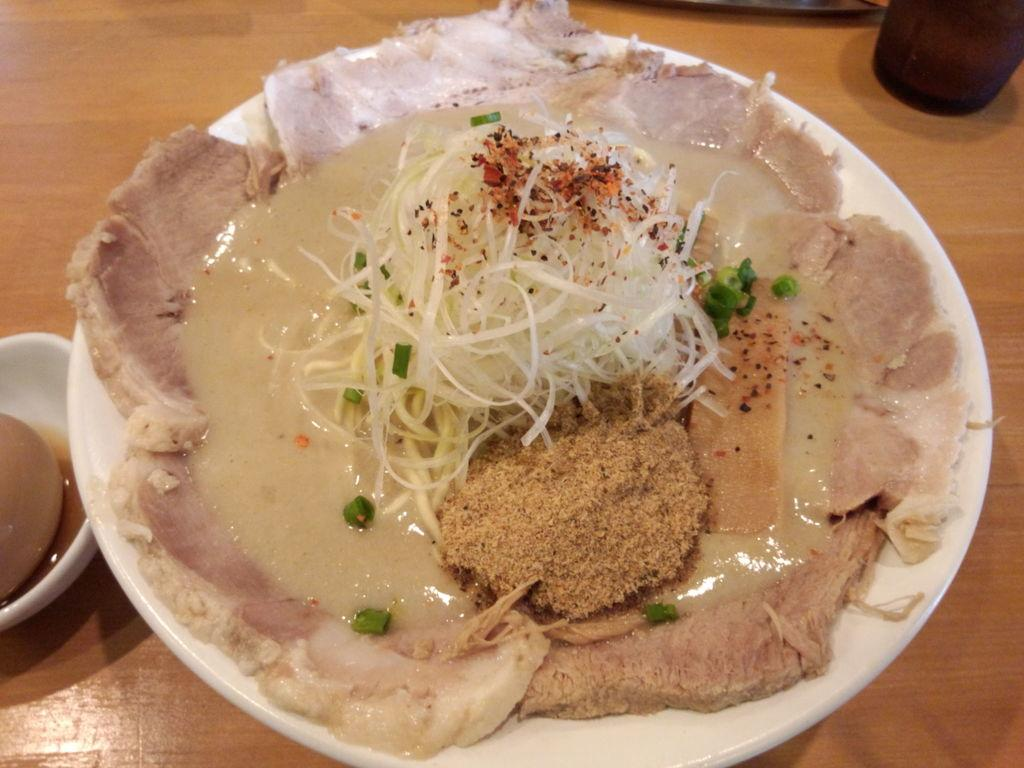What is on the white plate in the image? There are food items and ingredients on a white plate. Where is the plate located? The plate is placed on a wooden table. What else can be seen on the wooden table? There is a cup on the wooden table. Is there anything else on the wooden table besides the plate and cup? Yes, there is an unspecified object on the wooden table. How does the wooden table support the dust particles in the image? The wooden table does not support dust particles in the image; there is no mention of dust in the provided facts. 